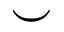Convert formula to latex. <formula><loc_0><loc_0><loc_500><loc_500>\smile</formula> 